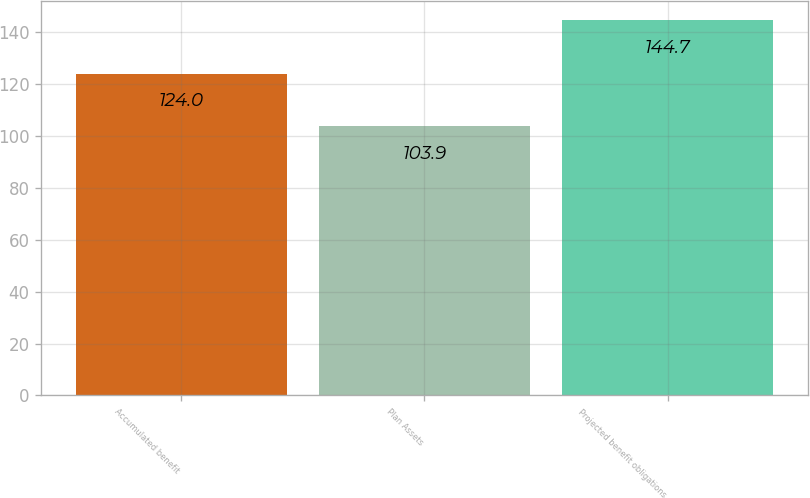<chart> <loc_0><loc_0><loc_500><loc_500><bar_chart><fcel>Accumulated benefit<fcel>Plan Assets<fcel>Projected benefit obligations<nl><fcel>124<fcel>103.9<fcel>144.7<nl></chart> 